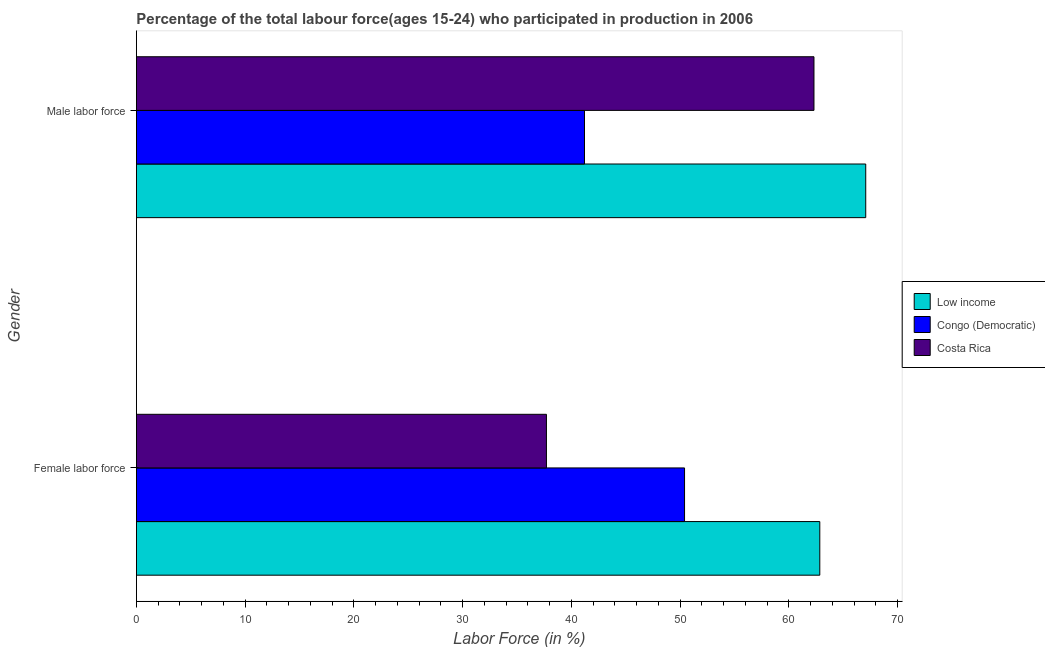Are the number of bars per tick equal to the number of legend labels?
Provide a short and direct response. Yes. Are the number of bars on each tick of the Y-axis equal?
Keep it short and to the point. Yes. How many bars are there on the 1st tick from the top?
Provide a short and direct response. 3. What is the label of the 2nd group of bars from the top?
Offer a terse response. Female labor force. What is the percentage of male labour force in Congo (Democratic)?
Offer a terse response. 41.2. Across all countries, what is the maximum percentage of female labor force?
Make the answer very short. 62.84. Across all countries, what is the minimum percentage of male labour force?
Provide a short and direct response. 41.2. In which country was the percentage of male labour force minimum?
Provide a succinct answer. Congo (Democratic). What is the total percentage of female labor force in the graph?
Ensure brevity in your answer.  150.94. What is the difference between the percentage of female labor force in Costa Rica and that in Low income?
Give a very brief answer. -25.14. What is the difference between the percentage of female labor force in Costa Rica and the percentage of male labour force in Low income?
Offer a terse response. -29.36. What is the average percentage of female labor force per country?
Provide a short and direct response. 50.31. What is the difference between the percentage of female labor force and percentage of male labour force in Low income?
Your answer should be very brief. -4.22. What is the ratio of the percentage of male labour force in Congo (Democratic) to that in Low income?
Your answer should be compact. 0.61. What does the 3rd bar from the top in Male labor force represents?
Offer a very short reply. Low income. What does the 2nd bar from the bottom in Male labor force represents?
Ensure brevity in your answer.  Congo (Democratic). Are all the bars in the graph horizontal?
Offer a terse response. Yes. How many countries are there in the graph?
Keep it short and to the point. 3. Does the graph contain grids?
Your answer should be compact. No. Where does the legend appear in the graph?
Keep it short and to the point. Center right. What is the title of the graph?
Provide a succinct answer. Percentage of the total labour force(ages 15-24) who participated in production in 2006. Does "High income" appear as one of the legend labels in the graph?
Make the answer very short. No. What is the label or title of the X-axis?
Offer a terse response. Labor Force (in %). What is the label or title of the Y-axis?
Ensure brevity in your answer.  Gender. What is the Labor Force (in %) of Low income in Female labor force?
Offer a terse response. 62.84. What is the Labor Force (in %) in Congo (Democratic) in Female labor force?
Provide a short and direct response. 50.4. What is the Labor Force (in %) in Costa Rica in Female labor force?
Provide a succinct answer. 37.7. What is the Labor Force (in %) of Low income in Male labor force?
Your answer should be compact. 67.06. What is the Labor Force (in %) in Congo (Democratic) in Male labor force?
Ensure brevity in your answer.  41.2. What is the Labor Force (in %) in Costa Rica in Male labor force?
Provide a short and direct response. 62.3. Across all Gender, what is the maximum Labor Force (in %) of Low income?
Your response must be concise. 67.06. Across all Gender, what is the maximum Labor Force (in %) of Congo (Democratic)?
Make the answer very short. 50.4. Across all Gender, what is the maximum Labor Force (in %) of Costa Rica?
Provide a succinct answer. 62.3. Across all Gender, what is the minimum Labor Force (in %) of Low income?
Your answer should be very brief. 62.84. Across all Gender, what is the minimum Labor Force (in %) in Congo (Democratic)?
Your response must be concise. 41.2. Across all Gender, what is the minimum Labor Force (in %) of Costa Rica?
Keep it short and to the point. 37.7. What is the total Labor Force (in %) of Low income in the graph?
Provide a short and direct response. 129.89. What is the total Labor Force (in %) of Congo (Democratic) in the graph?
Offer a terse response. 91.6. What is the total Labor Force (in %) of Costa Rica in the graph?
Ensure brevity in your answer.  100. What is the difference between the Labor Force (in %) of Low income in Female labor force and that in Male labor force?
Keep it short and to the point. -4.22. What is the difference between the Labor Force (in %) of Costa Rica in Female labor force and that in Male labor force?
Your answer should be very brief. -24.6. What is the difference between the Labor Force (in %) of Low income in Female labor force and the Labor Force (in %) of Congo (Democratic) in Male labor force?
Offer a very short reply. 21.64. What is the difference between the Labor Force (in %) in Low income in Female labor force and the Labor Force (in %) in Costa Rica in Male labor force?
Make the answer very short. 0.54. What is the average Labor Force (in %) in Low income per Gender?
Give a very brief answer. 64.95. What is the average Labor Force (in %) in Congo (Democratic) per Gender?
Give a very brief answer. 45.8. What is the difference between the Labor Force (in %) in Low income and Labor Force (in %) in Congo (Democratic) in Female labor force?
Make the answer very short. 12.44. What is the difference between the Labor Force (in %) of Low income and Labor Force (in %) of Costa Rica in Female labor force?
Ensure brevity in your answer.  25.14. What is the difference between the Labor Force (in %) of Low income and Labor Force (in %) of Congo (Democratic) in Male labor force?
Offer a terse response. 25.86. What is the difference between the Labor Force (in %) of Low income and Labor Force (in %) of Costa Rica in Male labor force?
Make the answer very short. 4.76. What is the difference between the Labor Force (in %) of Congo (Democratic) and Labor Force (in %) of Costa Rica in Male labor force?
Your response must be concise. -21.1. What is the ratio of the Labor Force (in %) in Low income in Female labor force to that in Male labor force?
Your answer should be compact. 0.94. What is the ratio of the Labor Force (in %) in Congo (Democratic) in Female labor force to that in Male labor force?
Offer a very short reply. 1.22. What is the ratio of the Labor Force (in %) of Costa Rica in Female labor force to that in Male labor force?
Provide a short and direct response. 0.61. What is the difference between the highest and the second highest Labor Force (in %) of Low income?
Give a very brief answer. 4.22. What is the difference between the highest and the second highest Labor Force (in %) of Costa Rica?
Provide a short and direct response. 24.6. What is the difference between the highest and the lowest Labor Force (in %) in Low income?
Your answer should be compact. 4.22. What is the difference between the highest and the lowest Labor Force (in %) of Congo (Democratic)?
Your response must be concise. 9.2. What is the difference between the highest and the lowest Labor Force (in %) in Costa Rica?
Offer a very short reply. 24.6. 